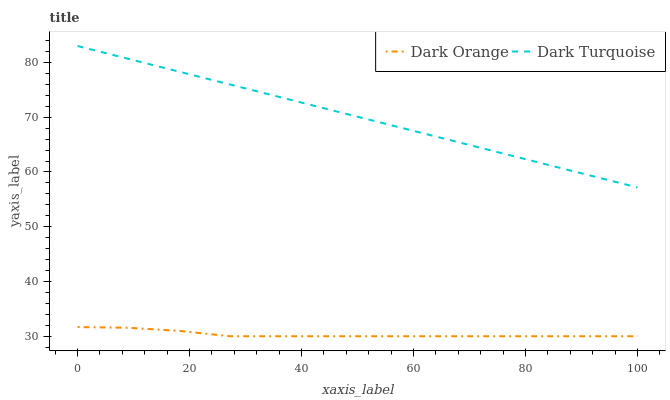Does Dark Orange have the minimum area under the curve?
Answer yes or no. Yes. Does Dark Turquoise have the maximum area under the curve?
Answer yes or no. Yes. Does Dark Turquoise have the minimum area under the curve?
Answer yes or no. No. Is Dark Turquoise the smoothest?
Answer yes or no. Yes. Is Dark Orange the roughest?
Answer yes or no. Yes. Is Dark Turquoise the roughest?
Answer yes or no. No. Does Dark Orange have the lowest value?
Answer yes or no. Yes. Does Dark Turquoise have the lowest value?
Answer yes or no. No. Does Dark Turquoise have the highest value?
Answer yes or no. Yes. Is Dark Orange less than Dark Turquoise?
Answer yes or no. Yes. Is Dark Turquoise greater than Dark Orange?
Answer yes or no. Yes. Does Dark Orange intersect Dark Turquoise?
Answer yes or no. No. 